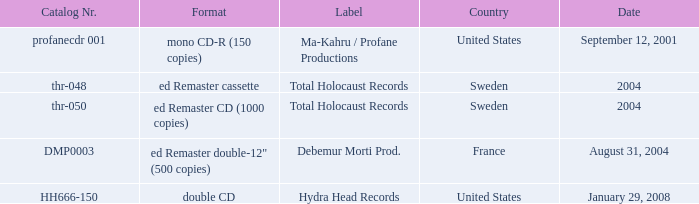What date features total holocaust records in the ed remaster audio tape format? 2004.0. 